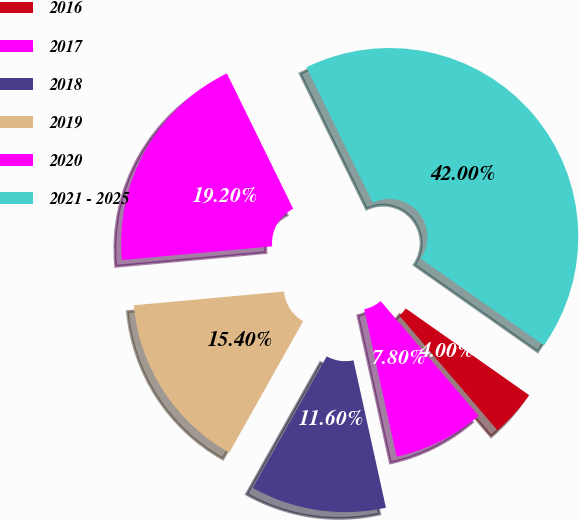<chart> <loc_0><loc_0><loc_500><loc_500><pie_chart><fcel>2016<fcel>2017<fcel>2018<fcel>2019<fcel>2020<fcel>2021 - 2025<nl><fcel>4.0%<fcel>7.8%<fcel>11.6%<fcel>15.4%<fcel>19.2%<fcel>42.0%<nl></chart> 